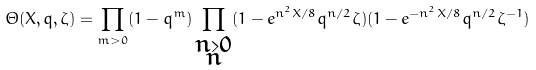<formula> <loc_0><loc_0><loc_500><loc_500>\Theta ( X , q , \zeta ) = \prod _ { m > 0 } ( 1 - q ^ { m } ) \prod _ { \substack { n > 0 \\ n } } ( 1 - e ^ { n ^ { 2 } X / 8 } q ^ { n / 2 } \zeta ) ( 1 - e ^ { - n ^ { 2 } X / 8 } q ^ { n / 2 } \zeta ^ { - 1 } )</formula> 